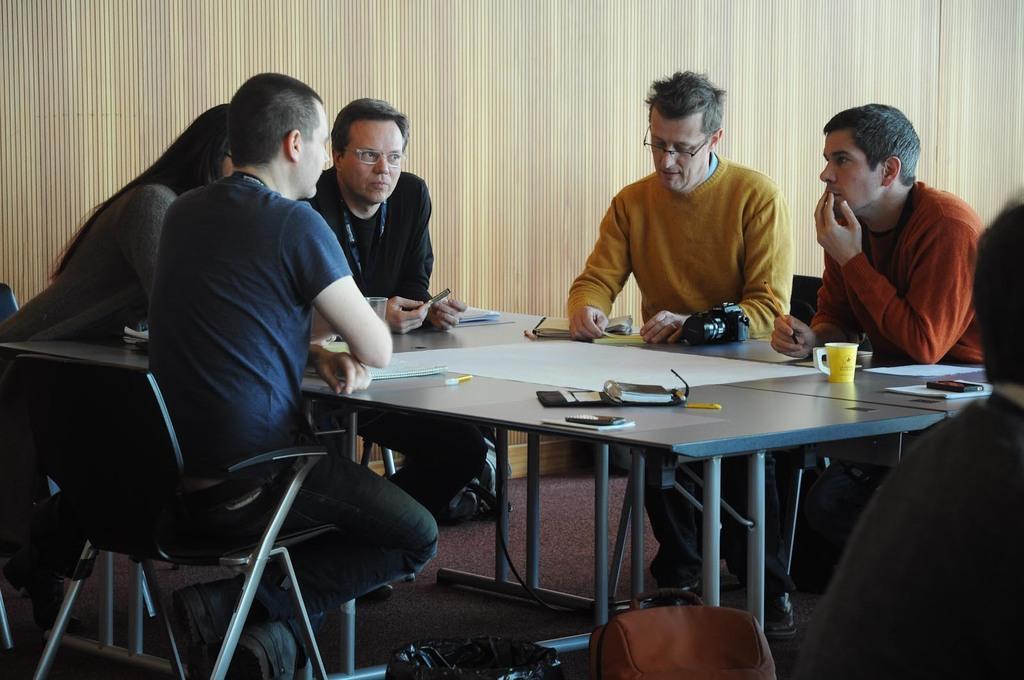Can you describe this image briefly? Here we can see a person sitting on the chair ,and in front here is the table and papers and cup and some objects on it ,and at back here is the curtain. 